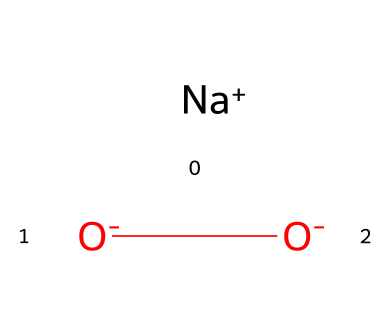What is the molecular formula of the chemical? The SMILES representation indicates the presence of sodium (Na), oxygen (O) and two negatively charged oxygen atoms. Together, this can be summarized as Na2O2, which corresponds to the molecular formula.
Answer: Na2O2 How many oxygen atoms are present in this structure? By examining the SMILES notation, we see that there are three oxygen atoms: two in the form of O- and one bonded to sodium.
Answer: three What is the charge of the chemical? The SMILES shows that there is one sodium ion with a positive charge ([Na+]) and two oxygen ions both with negative charges ([O-][O-]), resulting in an overall charge of zero when combined.
Answer: zero What type of chemical is this? The presence of sodium and oxygen in its structure, along with the context of using this in detergents, indicates that this is a type of bleaching agent, specifically for its oxygen-based properties.
Answer: bleaching agent Why is this compound effective in stain removal? The two negatively charged oxygen atoms can readily react with organic stains, breaking them down through oxidation, thus making this compound effective for stain removal as a bleaching agent in detergents.
Answer: oxidation What role does sodium play in this compound? Sodium serves as a counterion that balances the negative charges of the two oxygen atoms, helping to stabilize the overall structure and making it soluble in water, which is essential for its use as a detergent.
Answer: stabilizing Is this compound soluble in water? Yes, the presence of sodium ions typically indicates that the compound is ionic and thus soluble in water, enhancing its effectiveness as a detergent in various cleaning applications.
Answer: yes 